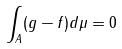<formula> <loc_0><loc_0><loc_500><loc_500>\int _ { A } ( g - f ) d \mu = 0</formula> 